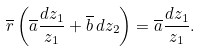<formula> <loc_0><loc_0><loc_500><loc_500>\overline { r } \left ( \overline { a } \frac { d z _ { 1 } } { z _ { 1 } } + \overline { b } \, d z _ { 2 } \right ) = \overline { a } \frac { d z _ { 1 } } { z _ { 1 } } .</formula> 